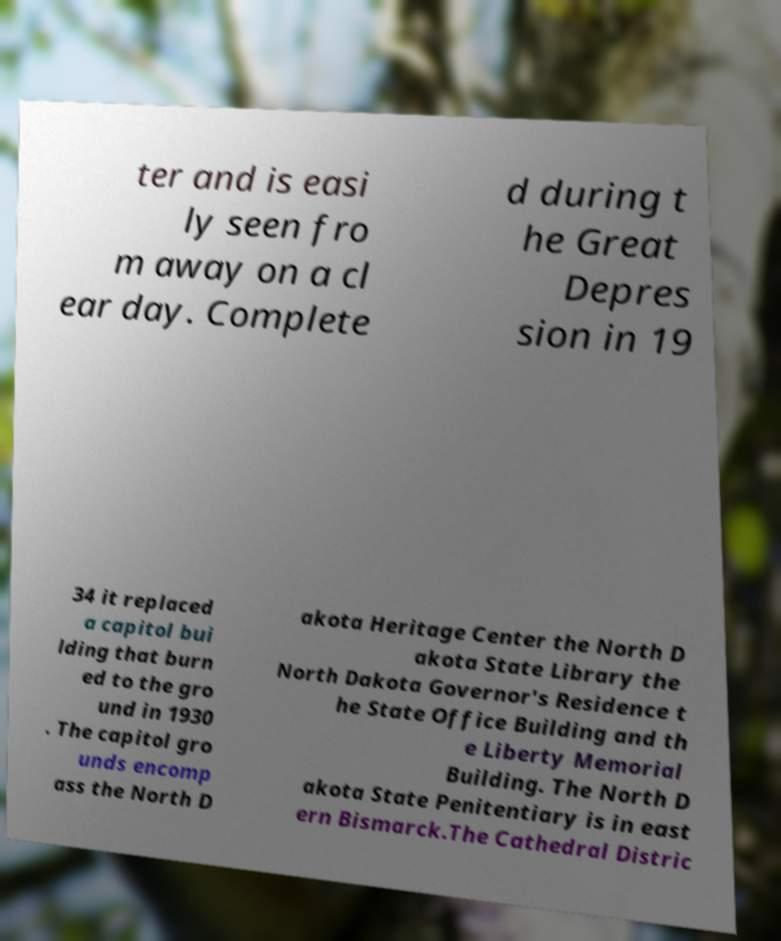What messages or text are displayed in this image? I need them in a readable, typed format. ter and is easi ly seen fro m away on a cl ear day. Complete d during t he Great Depres sion in 19 34 it replaced a capitol bui lding that burn ed to the gro und in 1930 . The capitol gro unds encomp ass the North D akota Heritage Center the North D akota State Library the North Dakota Governor's Residence t he State Office Building and th e Liberty Memorial Building. The North D akota State Penitentiary is in east ern Bismarck.The Cathedral Distric 